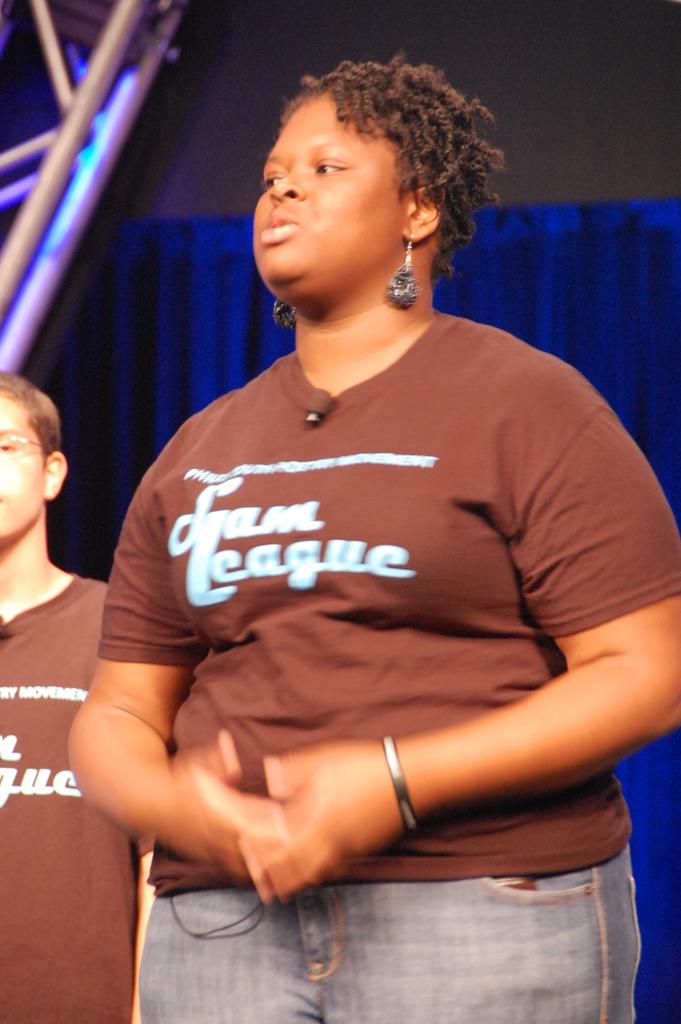What is the bottom-most word on the shirt?
Make the answer very short. League. What organization is she with?
Give a very brief answer. Slam league. 